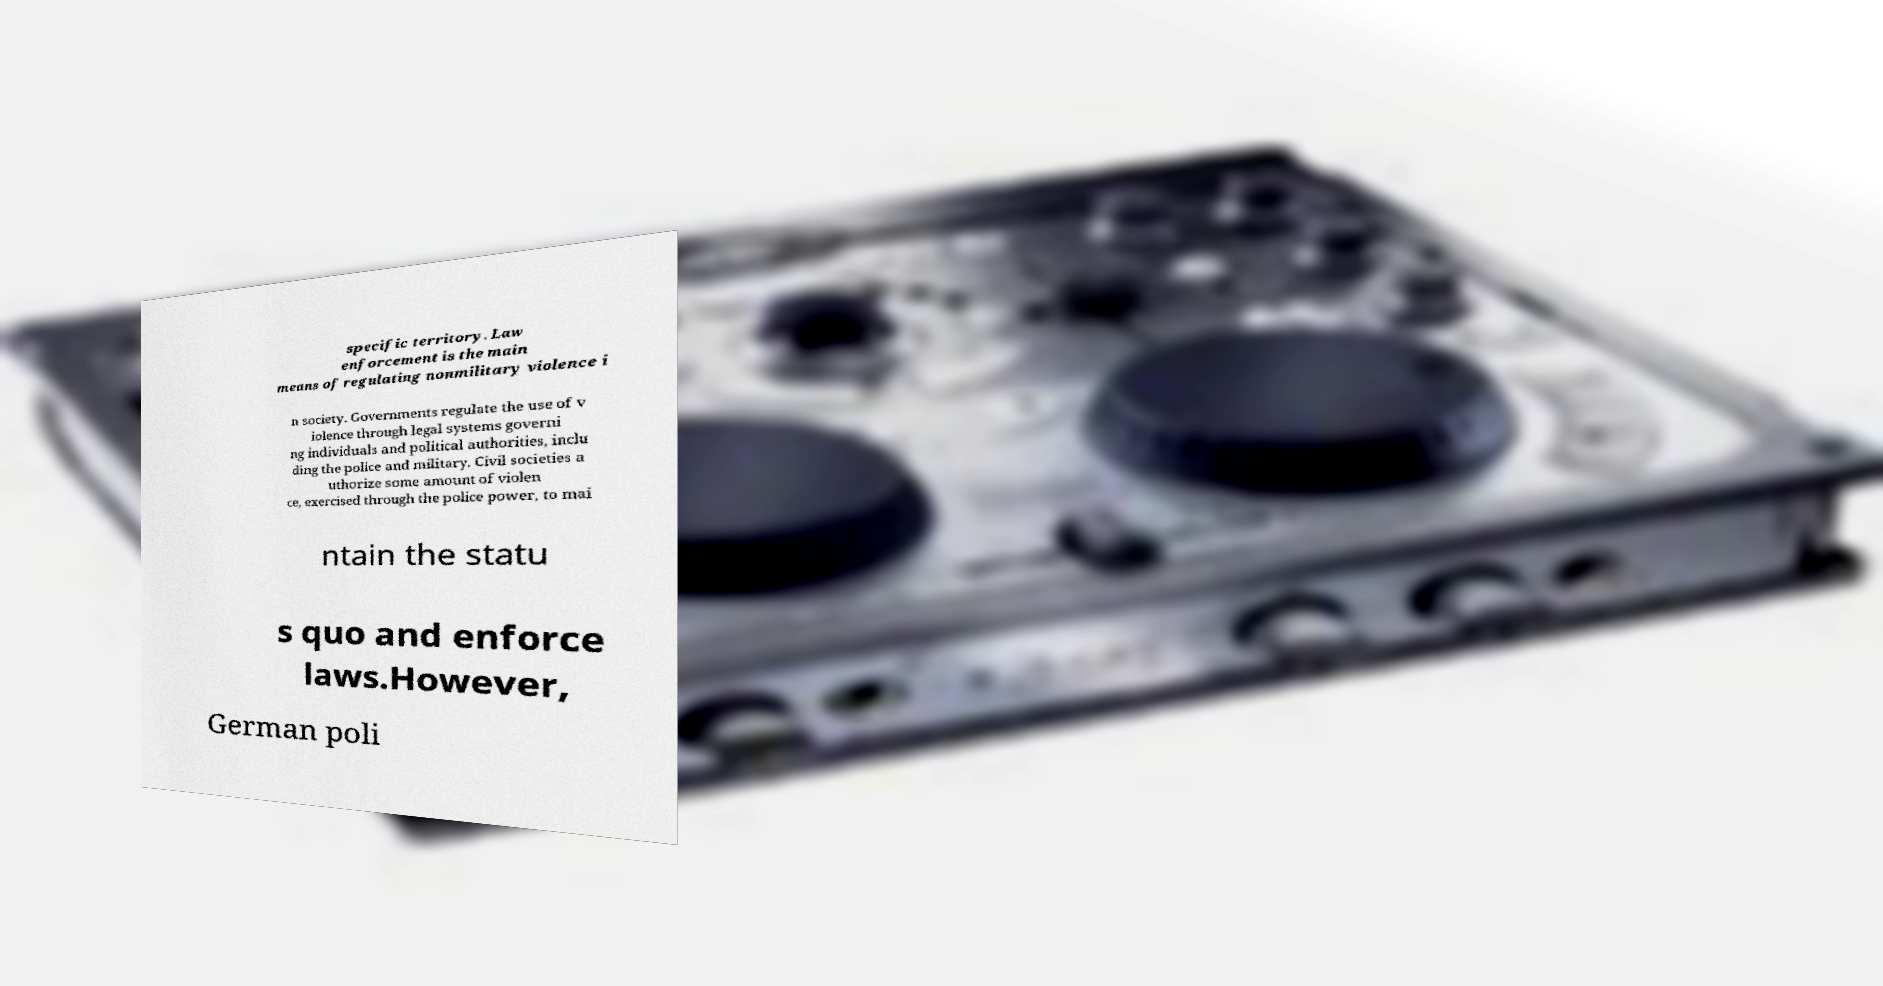There's text embedded in this image that I need extracted. Can you transcribe it verbatim? specific territory. Law enforcement is the main means of regulating nonmilitary violence i n society. Governments regulate the use of v iolence through legal systems governi ng individuals and political authorities, inclu ding the police and military. Civil societies a uthorize some amount of violen ce, exercised through the police power, to mai ntain the statu s quo and enforce laws.However, German poli 